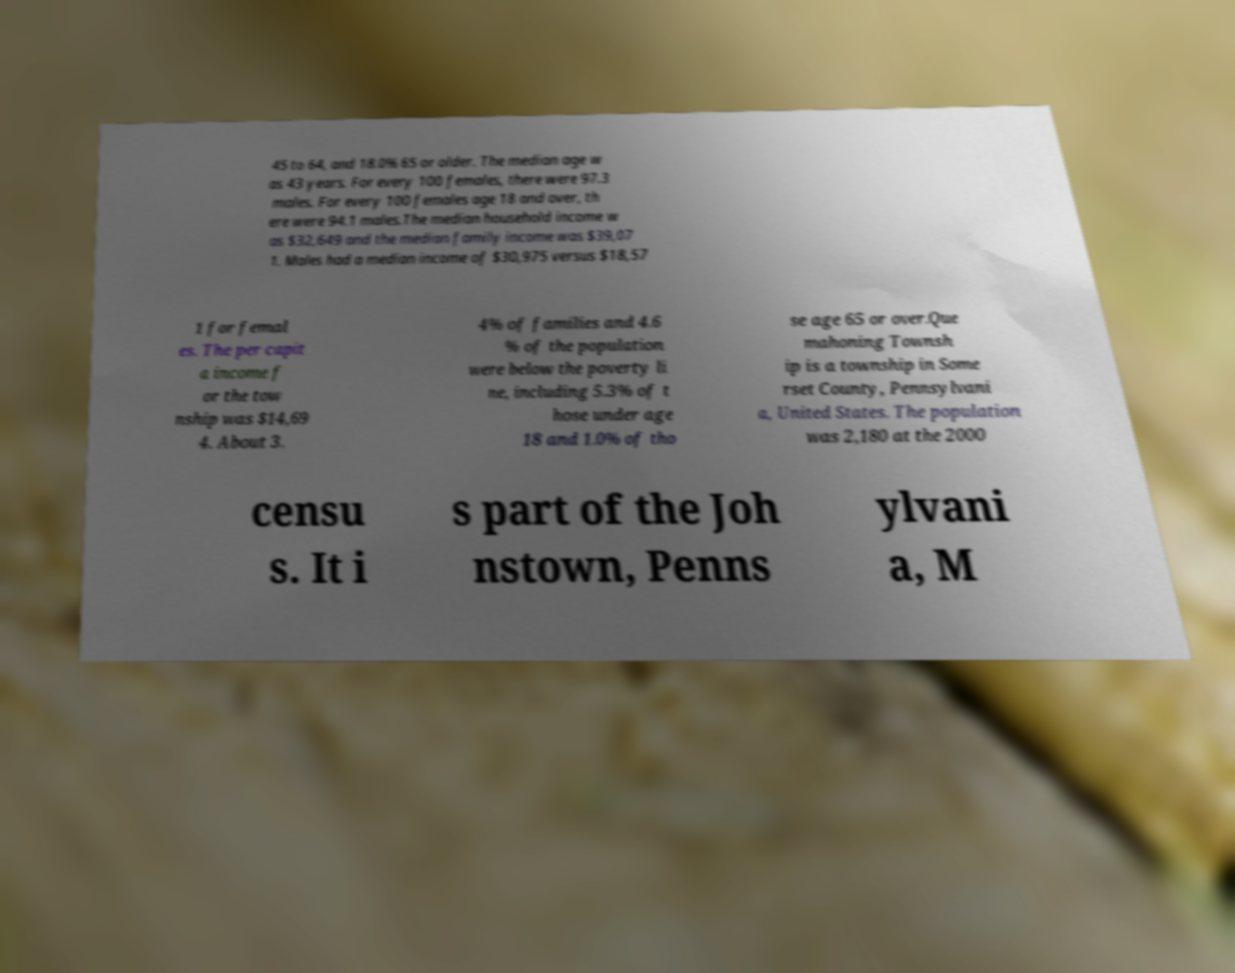Please identify and transcribe the text found in this image. 45 to 64, and 18.0% 65 or older. The median age w as 43 years. For every 100 females, there were 97.3 males. For every 100 females age 18 and over, th ere were 94.1 males.The median household income w as $32,649 and the median family income was $39,07 1. Males had a median income of $30,975 versus $18,57 1 for femal es. The per capit a income f or the tow nship was $14,69 4. About 3. 4% of families and 4.6 % of the population were below the poverty li ne, including 5.3% of t hose under age 18 and 1.0% of tho se age 65 or over.Que mahoning Townsh ip is a township in Some rset County, Pennsylvani a, United States. The population was 2,180 at the 2000 censu s. It i s part of the Joh nstown, Penns ylvani a, M 